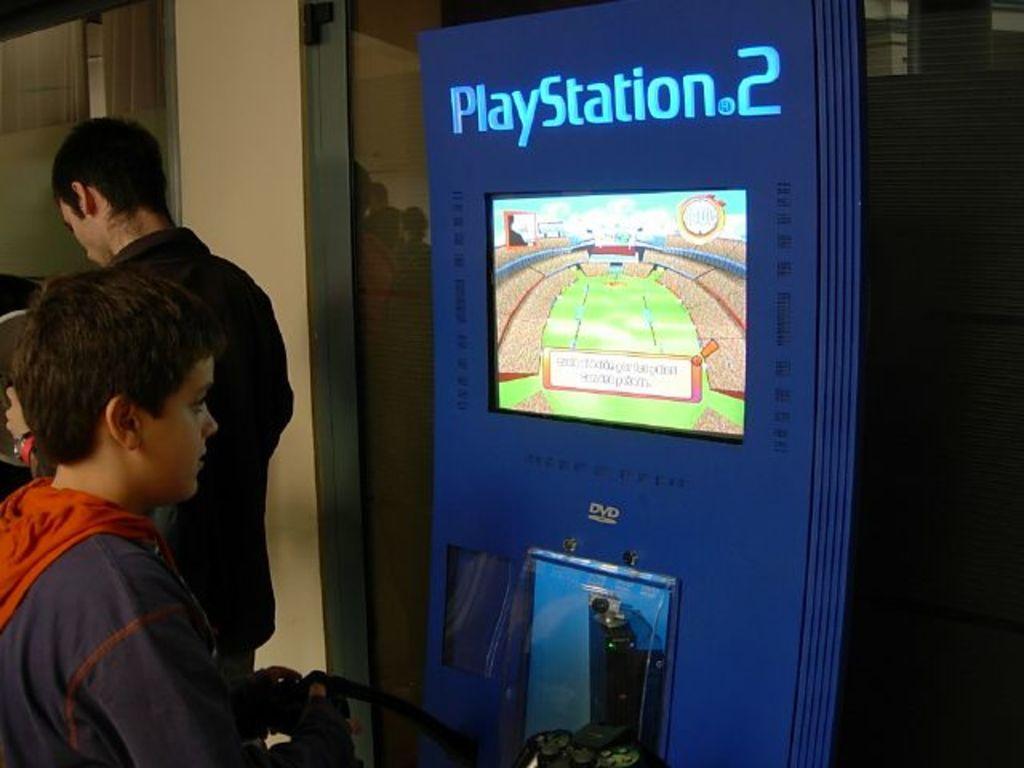Can you describe this image briefly? In this image there is a boy holding a joystick in his hand. Before him there is a playstation having a screen. Left side there is a person standing. Background there is a glass wall having the reflection of few people. 